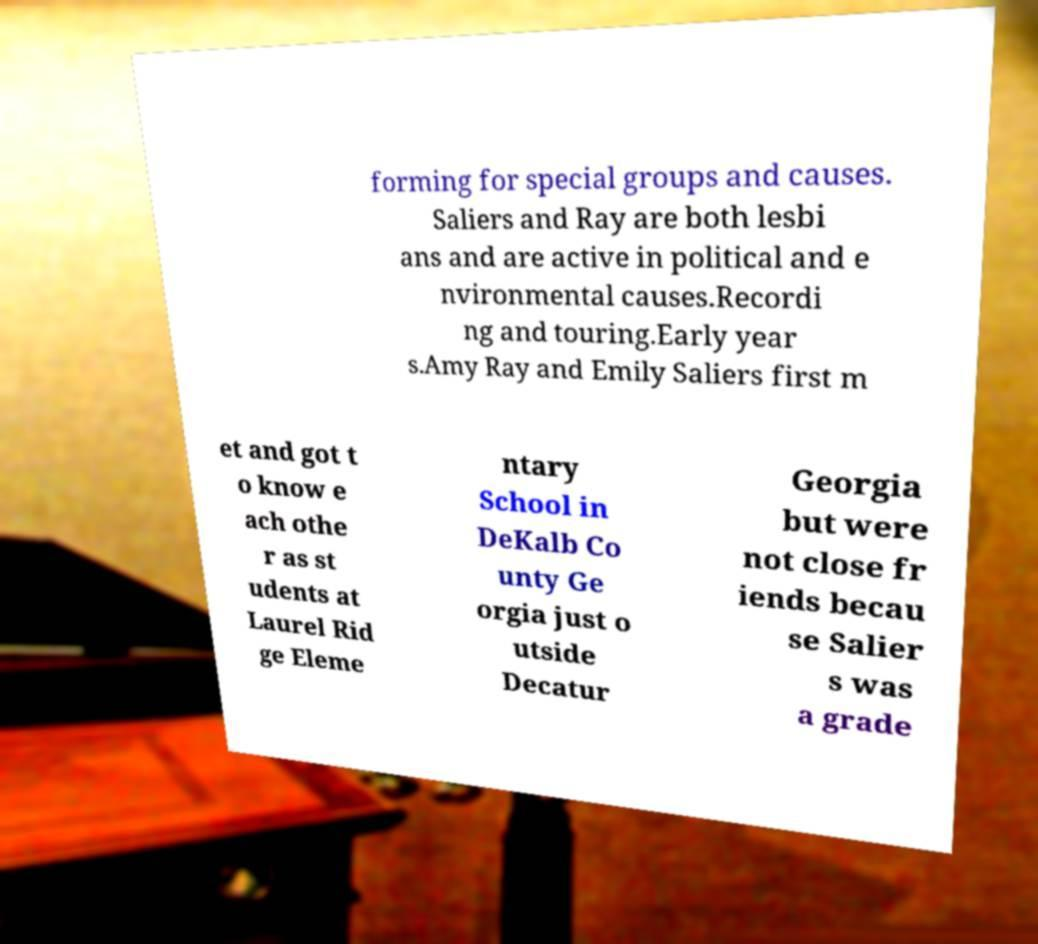Could you extract and type out the text from this image? forming for special groups and causes. Saliers and Ray are both lesbi ans and are active in political and e nvironmental causes.Recordi ng and touring.Early year s.Amy Ray and Emily Saliers first m et and got t o know e ach othe r as st udents at Laurel Rid ge Eleme ntary School in DeKalb Co unty Ge orgia just o utside Decatur Georgia but were not close fr iends becau se Salier s was a grade 